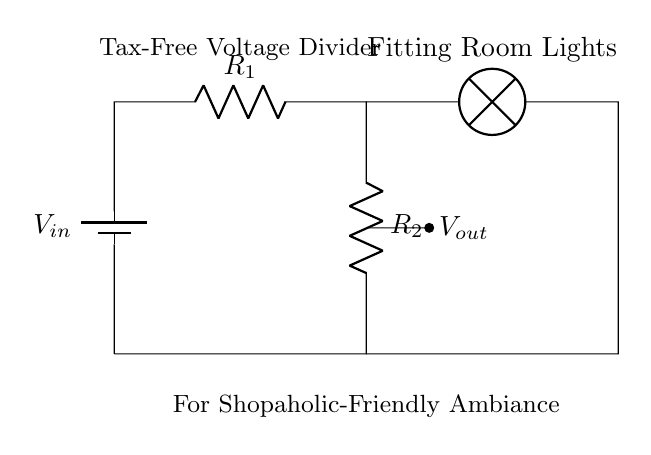What is the input voltage of the circuit? The input voltage, V\_{in}, is indicated at the battery symbol at the left side of the circuit diagram. However, a specific numerical value is not provided, only that it is labeled.
Answer: V\_{in} What type of components are R1 and R2? R1 and R2 are both resistors, as indicated by the R label next to their symbols in the circuit.
Answer: Resistors What is the purpose of the lamp in the circuit? The lamp is labeled as "Fitting Room Lights," suggesting its role is to provide illumination in the fitting room, likely to enhance the shopping experience.
Answer: Illumination How many resistors are in this voltage divider circuit? The circuit contains two resistors, R1 and R2, and they are arranged in series as part of the voltage divider to reduce the voltage for the lamp.
Answer: Two What is the output voltage affecting the lamp? The output voltage, V\_{out}, is taken from the middle point between R1 and R2. This voltage is directly related to the values of R1 and R2 and is what powers the lamp.
Answer: V\_{out} What is the function of the voltage divider in this circuit? The voltage divider's function is to reduce the supply voltage to a lower voltage level (V\_{out}) suitable for powering the lamp, allowing for dimming effects.
Answer: Dimming What ambiance is suggested by the circuit design? The design includes "Shopaholic-Friendly Ambiance" in the notes, implying that the dim lighting is likely intended to create a comfortable and appealing environment for shoppers.
Answer: Comfortable ambiance 